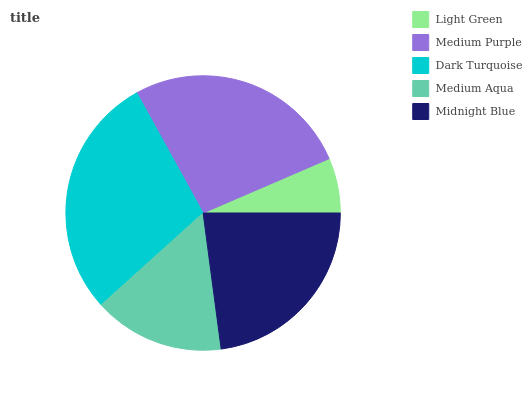Is Light Green the minimum?
Answer yes or no. Yes. Is Dark Turquoise the maximum?
Answer yes or no. Yes. Is Medium Purple the minimum?
Answer yes or no. No. Is Medium Purple the maximum?
Answer yes or no. No. Is Medium Purple greater than Light Green?
Answer yes or no. Yes. Is Light Green less than Medium Purple?
Answer yes or no. Yes. Is Light Green greater than Medium Purple?
Answer yes or no. No. Is Medium Purple less than Light Green?
Answer yes or no. No. Is Midnight Blue the high median?
Answer yes or no. Yes. Is Midnight Blue the low median?
Answer yes or no. Yes. Is Dark Turquoise the high median?
Answer yes or no. No. Is Dark Turquoise the low median?
Answer yes or no. No. 